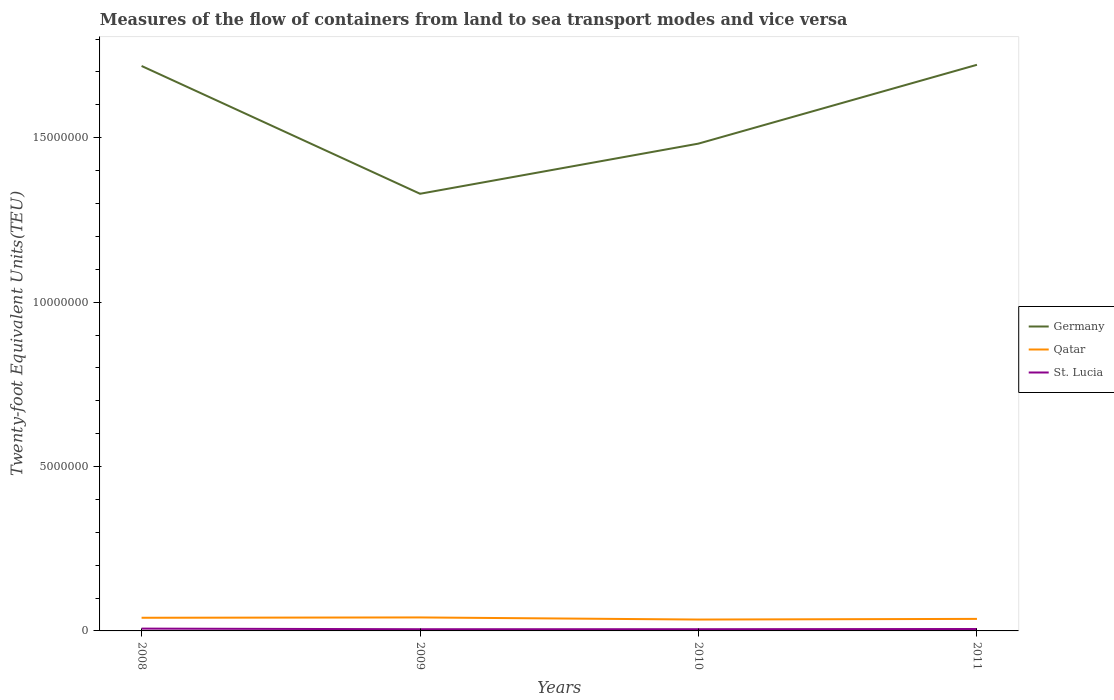Does the line corresponding to Germany intersect with the line corresponding to Qatar?
Provide a short and direct response. No. Across all years, what is the maximum container port traffic in Qatar?
Offer a terse response. 3.46e+05. In which year was the container port traffic in Qatar maximum?
Provide a short and direct response. 2010. What is the total container port traffic in Qatar in the graph?
Give a very brief answer. 5.40e+04. What is the difference between the highest and the second highest container port traffic in Qatar?
Offer a terse response. 6.40e+04. How many lines are there?
Your response must be concise. 3. What is the difference between two consecutive major ticks on the Y-axis?
Make the answer very short. 5.00e+06. Are the values on the major ticks of Y-axis written in scientific E-notation?
Your response must be concise. No. Does the graph contain any zero values?
Provide a short and direct response. No. Does the graph contain grids?
Offer a very short reply. No. How are the legend labels stacked?
Offer a very short reply. Vertical. What is the title of the graph?
Your response must be concise. Measures of the flow of containers from land to sea transport modes and vice versa. What is the label or title of the Y-axis?
Keep it short and to the point. Twenty-foot Equivalent Units(TEU). What is the Twenty-foot Equivalent Units(TEU) of Germany in 2008?
Your response must be concise. 1.72e+07. What is the Twenty-foot Equivalent Units(TEU) of St. Lucia in 2008?
Keep it short and to the point. 7.02e+04. What is the Twenty-foot Equivalent Units(TEU) of Germany in 2009?
Provide a succinct answer. 1.33e+07. What is the Twenty-foot Equivalent Units(TEU) of St. Lucia in 2009?
Keep it short and to the point. 5.19e+04. What is the Twenty-foot Equivalent Units(TEU) in Germany in 2010?
Provide a succinct answer. 1.48e+07. What is the Twenty-foot Equivalent Units(TEU) in Qatar in 2010?
Your answer should be very brief. 3.46e+05. What is the Twenty-foot Equivalent Units(TEU) of St. Lucia in 2010?
Keep it short and to the point. 5.25e+04. What is the Twenty-foot Equivalent Units(TEU) of Germany in 2011?
Ensure brevity in your answer.  1.72e+07. What is the Twenty-foot Equivalent Units(TEU) in Qatar in 2011?
Your answer should be compact. 3.66e+05. What is the Twenty-foot Equivalent Units(TEU) in St. Lucia in 2011?
Offer a terse response. 5.85e+04. Across all years, what is the maximum Twenty-foot Equivalent Units(TEU) in Germany?
Offer a terse response. 1.72e+07. Across all years, what is the maximum Twenty-foot Equivalent Units(TEU) of St. Lucia?
Offer a terse response. 7.02e+04. Across all years, what is the minimum Twenty-foot Equivalent Units(TEU) in Germany?
Give a very brief answer. 1.33e+07. Across all years, what is the minimum Twenty-foot Equivalent Units(TEU) of Qatar?
Give a very brief answer. 3.46e+05. Across all years, what is the minimum Twenty-foot Equivalent Units(TEU) in St. Lucia?
Ensure brevity in your answer.  5.19e+04. What is the total Twenty-foot Equivalent Units(TEU) in Germany in the graph?
Your answer should be compact. 6.25e+07. What is the total Twenty-foot Equivalent Units(TEU) of Qatar in the graph?
Keep it short and to the point. 1.52e+06. What is the total Twenty-foot Equivalent Units(TEU) in St. Lucia in the graph?
Provide a succinct answer. 2.33e+05. What is the difference between the Twenty-foot Equivalent Units(TEU) of Germany in 2008 and that in 2009?
Your response must be concise. 3.89e+06. What is the difference between the Twenty-foot Equivalent Units(TEU) in Qatar in 2008 and that in 2009?
Your answer should be compact. -10000. What is the difference between the Twenty-foot Equivalent Units(TEU) in St. Lucia in 2008 and that in 2009?
Ensure brevity in your answer.  1.83e+04. What is the difference between the Twenty-foot Equivalent Units(TEU) in Germany in 2008 and that in 2010?
Offer a very short reply. 2.36e+06. What is the difference between the Twenty-foot Equivalent Units(TEU) in Qatar in 2008 and that in 2010?
Give a very brief answer. 5.40e+04. What is the difference between the Twenty-foot Equivalent Units(TEU) of St. Lucia in 2008 and that in 2010?
Your answer should be compact. 1.77e+04. What is the difference between the Twenty-foot Equivalent Units(TEU) of Germany in 2008 and that in 2011?
Make the answer very short. -3.57e+04. What is the difference between the Twenty-foot Equivalent Units(TEU) in Qatar in 2008 and that in 2011?
Ensure brevity in your answer.  3.43e+04. What is the difference between the Twenty-foot Equivalent Units(TEU) of St. Lucia in 2008 and that in 2011?
Offer a very short reply. 1.17e+04. What is the difference between the Twenty-foot Equivalent Units(TEU) in Germany in 2009 and that in 2010?
Ensure brevity in your answer.  -1.53e+06. What is the difference between the Twenty-foot Equivalent Units(TEU) of Qatar in 2009 and that in 2010?
Give a very brief answer. 6.40e+04. What is the difference between the Twenty-foot Equivalent Units(TEU) of St. Lucia in 2009 and that in 2010?
Provide a succinct answer. -537. What is the difference between the Twenty-foot Equivalent Units(TEU) of Germany in 2009 and that in 2011?
Offer a terse response. -3.92e+06. What is the difference between the Twenty-foot Equivalent Units(TEU) of Qatar in 2009 and that in 2011?
Your response must be concise. 4.43e+04. What is the difference between the Twenty-foot Equivalent Units(TEU) in St. Lucia in 2009 and that in 2011?
Your answer should be very brief. -6596.94. What is the difference between the Twenty-foot Equivalent Units(TEU) in Germany in 2010 and that in 2011?
Your answer should be very brief. -2.40e+06. What is the difference between the Twenty-foot Equivalent Units(TEU) of Qatar in 2010 and that in 2011?
Your answer should be very brief. -1.97e+04. What is the difference between the Twenty-foot Equivalent Units(TEU) of St. Lucia in 2010 and that in 2011?
Offer a very short reply. -6059.94. What is the difference between the Twenty-foot Equivalent Units(TEU) of Germany in 2008 and the Twenty-foot Equivalent Units(TEU) of Qatar in 2009?
Ensure brevity in your answer.  1.68e+07. What is the difference between the Twenty-foot Equivalent Units(TEU) of Germany in 2008 and the Twenty-foot Equivalent Units(TEU) of St. Lucia in 2009?
Offer a terse response. 1.71e+07. What is the difference between the Twenty-foot Equivalent Units(TEU) of Qatar in 2008 and the Twenty-foot Equivalent Units(TEU) of St. Lucia in 2009?
Your response must be concise. 3.48e+05. What is the difference between the Twenty-foot Equivalent Units(TEU) of Germany in 2008 and the Twenty-foot Equivalent Units(TEU) of Qatar in 2010?
Ensure brevity in your answer.  1.68e+07. What is the difference between the Twenty-foot Equivalent Units(TEU) of Germany in 2008 and the Twenty-foot Equivalent Units(TEU) of St. Lucia in 2010?
Offer a very short reply. 1.71e+07. What is the difference between the Twenty-foot Equivalent Units(TEU) in Qatar in 2008 and the Twenty-foot Equivalent Units(TEU) in St. Lucia in 2010?
Ensure brevity in your answer.  3.48e+05. What is the difference between the Twenty-foot Equivalent Units(TEU) of Germany in 2008 and the Twenty-foot Equivalent Units(TEU) of Qatar in 2011?
Offer a terse response. 1.68e+07. What is the difference between the Twenty-foot Equivalent Units(TEU) of Germany in 2008 and the Twenty-foot Equivalent Units(TEU) of St. Lucia in 2011?
Your response must be concise. 1.71e+07. What is the difference between the Twenty-foot Equivalent Units(TEU) of Qatar in 2008 and the Twenty-foot Equivalent Units(TEU) of St. Lucia in 2011?
Your answer should be very brief. 3.41e+05. What is the difference between the Twenty-foot Equivalent Units(TEU) of Germany in 2009 and the Twenty-foot Equivalent Units(TEU) of Qatar in 2010?
Give a very brief answer. 1.30e+07. What is the difference between the Twenty-foot Equivalent Units(TEU) of Germany in 2009 and the Twenty-foot Equivalent Units(TEU) of St. Lucia in 2010?
Provide a succinct answer. 1.32e+07. What is the difference between the Twenty-foot Equivalent Units(TEU) of Qatar in 2009 and the Twenty-foot Equivalent Units(TEU) of St. Lucia in 2010?
Your answer should be very brief. 3.58e+05. What is the difference between the Twenty-foot Equivalent Units(TEU) in Germany in 2009 and the Twenty-foot Equivalent Units(TEU) in Qatar in 2011?
Your answer should be very brief. 1.29e+07. What is the difference between the Twenty-foot Equivalent Units(TEU) of Germany in 2009 and the Twenty-foot Equivalent Units(TEU) of St. Lucia in 2011?
Your response must be concise. 1.32e+07. What is the difference between the Twenty-foot Equivalent Units(TEU) of Qatar in 2009 and the Twenty-foot Equivalent Units(TEU) of St. Lucia in 2011?
Offer a terse response. 3.51e+05. What is the difference between the Twenty-foot Equivalent Units(TEU) in Germany in 2010 and the Twenty-foot Equivalent Units(TEU) in Qatar in 2011?
Your answer should be very brief. 1.45e+07. What is the difference between the Twenty-foot Equivalent Units(TEU) of Germany in 2010 and the Twenty-foot Equivalent Units(TEU) of St. Lucia in 2011?
Keep it short and to the point. 1.48e+07. What is the difference between the Twenty-foot Equivalent Units(TEU) in Qatar in 2010 and the Twenty-foot Equivalent Units(TEU) in St. Lucia in 2011?
Your answer should be very brief. 2.87e+05. What is the average Twenty-foot Equivalent Units(TEU) of Germany per year?
Offer a terse response. 1.56e+07. What is the average Twenty-foot Equivalent Units(TEU) in Qatar per year?
Offer a very short reply. 3.80e+05. What is the average Twenty-foot Equivalent Units(TEU) in St. Lucia per year?
Ensure brevity in your answer.  5.83e+04. In the year 2008, what is the difference between the Twenty-foot Equivalent Units(TEU) in Germany and Twenty-foot Equivalent Units(TEU) in Qatar?
Make the answer very short. 1.68e+07. In the year 2008, what is the difference between the Twenty-foot Equivalent Units(TEU) in Germany and Twenty-foot Equivalent Units(TEU) in St. Lucia?
Provide a short and direct response. 1.71e+07. In the year 2008, what is the difference between the Twenty-foot Equivalent Units(TEU) of Qatar and Twenty-foot Equivalent Units(TEU) of St. Lucia?
Keep it short and to the point. 3.30e+05. In the year 2009, what is the difference between the Twenty-foot Equivalent Units(TEU) in Germany and Twenty-foot Equivalent Units(TEU) in Qatar?
Give a very brief answer. 1.29e+07. In the year 2009, what is the difference between the Twenty-foot Equivalent Units(TEU) of Germany and Twenty-foot Equivalent Units(TEU) of St. Lucia?
Your answer should be compact. 1.32e+07. In the year 2009, what is the difference between the Twenty-foot Equivalent Units(TEU) in Qatar and Twenty-foot Equivalent Units(TEU) in St. Lucia?
Your answer should be compact. 3.58e+05. In the year 2010, what is the difference between the Twenty-foot Equivalent Units(TEU) of Germany and Twenty-foot Equivalent Units(TEU) of Qatar?
Offer a terse response. 1.45e+07. In the year 2010, what is the difference between the Twenty-foot Equivalent Units(TEU) in Germany and Twenty-foot Equivalent Units(TEU) in St. Lucia?
Provide a short and direct response. 1.48e+07. In the year 2010, what is the difference between the Twenty-foot Equivalent Units(TEU) of Qatar and Twenty-foot Equivalent Units(TEU) of St. Lucia?
Keep it short and to the point. 2.94e+05. In the year 2011, what is the difference between the Twenty-foot Equivalent Units(TEU) of Germany and Twenty-foot Equivalent Units(TEU) of Qatar?
Your response must be concise. 1.69e+07. In the year 2011, what is the difference between the Twenty-foot Equivalent Units(TEU) of Germany and Twenty-foot Equivalent Units(TEU) of St. Lucia?
Provide a succinct answer. 1.72e+07. In the year 2011, what is the difference between the Twenty-foot Equivalent Units(TEU) of Qatar and Twenty-foot Equivalent Units(TEU) of St. Lucia?
Give a very brief answer. 3.07e+05. What is the ratio of the Twenty-foot Equivalent Units(TEU) in Germany in 2008 to that in 2009?
Provide a short and direct response. 1.29. What is the ratio of the Twenty-foot Equivalent Units(TEU) in Qatar in 2008 to that in 2009?
Provide a short and direct response. 0.98. What is the ratio of the Twenty-foot Equivalent Units(TEU) of St. Lucia in 2008 to that in 2009?
Offer a terse response. 1.35. What is the ratio of the Twenty-foot Equivalent Units(TEU) of Germany in 2008 to that in 2010?
Give a very brief answer. 1.16. What is the ratio of the Twenty-foot Equivalent Units(TEU) in Qatar in 2008 to that in 2010?
Make the answer very short. 1.16. What is the ratio of the Twenty-foot Equivalent Units(TEU) of St. Lucia in 2008 to that in 2010?
Your response must be concise. 1.34. What is the ratio of the Twenty-foot Equivalent Units(TEU) in Germany in 2008 to that in 2011?
Give a very brief answer. 1. What is the ratio of the Twenty-foot Equivalent Units(TEU) of Qatar in 2008 to that in 2011?
Offer a terse response. 1.09. What is the ratio of the Twenty-foot Equivalent Units(TEU) in St. Lucia in 2008 to that in 2011?
Provide a succinct answer. 1.2. What is the ratio of the Twenty-foot Equivalent Units(TEU) in Germany in 2009 to that in 2010?
Give a very brief answer. 0.9. What is the ratio of the Twenty-foot Equivalent Units(TEU) of Qatar in 2009 to that in 2010?
Offer a terse response. 1.19. What is the ratio of the Twenty-foot Equivalent Units(TEU) in St. Lucia in 2009 to that in 2010?
Ensure brevity in your answer.  0.99. What is the ratio of the Twenty-foot Equivalent Units(TEU) in Germany in 2009 to that in 2011?
Ensure brevity in your answer.  0.77. What is the ratio of the Twenty-foot Equivalent Units(TEU) of Qatar in 2009 to that in 2011?
Offer a very short reply. 1.12. What is the ratio of the Twenty-foot Equivalent Units(TEU) in St. Lucia in 2009 to that in 2011?
Provide a succinct answer. 0.89. What is the ratio of the Twenty-foot Equivalent Units(TEU) in Germany in 2010 to that in 2011?
Make the answer very short. 0.86. What is the ratio of the Twenty-foot Equivalent Units(TEU) in Qatar in 2010 to that in 2011?
Keep it short and to the point. 0.95. What is the ratio of the Twenty-foot Equivalent Units(TEU) in St. Lucia in 2010 to that in 2011?
Ensure brevity in your answer.  0.9. What is the difference between the highest and the second highest Twenty-foot Equivalent Units(TEU) of Germany?
Make the answer very short. 3.57e+04. What is the difference between the highest and the second highest Twenty-foot Equivalent Units(TEU) of St. Lucia?
Offer a terse response. 1.17e+04. What is the difference between the highest and the lowest Twenty-foot Equivalent Units(TEU) in Germany?
Make the answer very short. 3.92e+06. What is the difference between the highest and the lowest Twenty-foot Equivalent Units(TEU) in Qatar?
Your response must be concise. 6.40e+04. What is the difference between the highest and the lowest Twenty-foot Equivalent Units(TEU) of St. Lucia?
Give a very brief answer. 1.83e+04. 